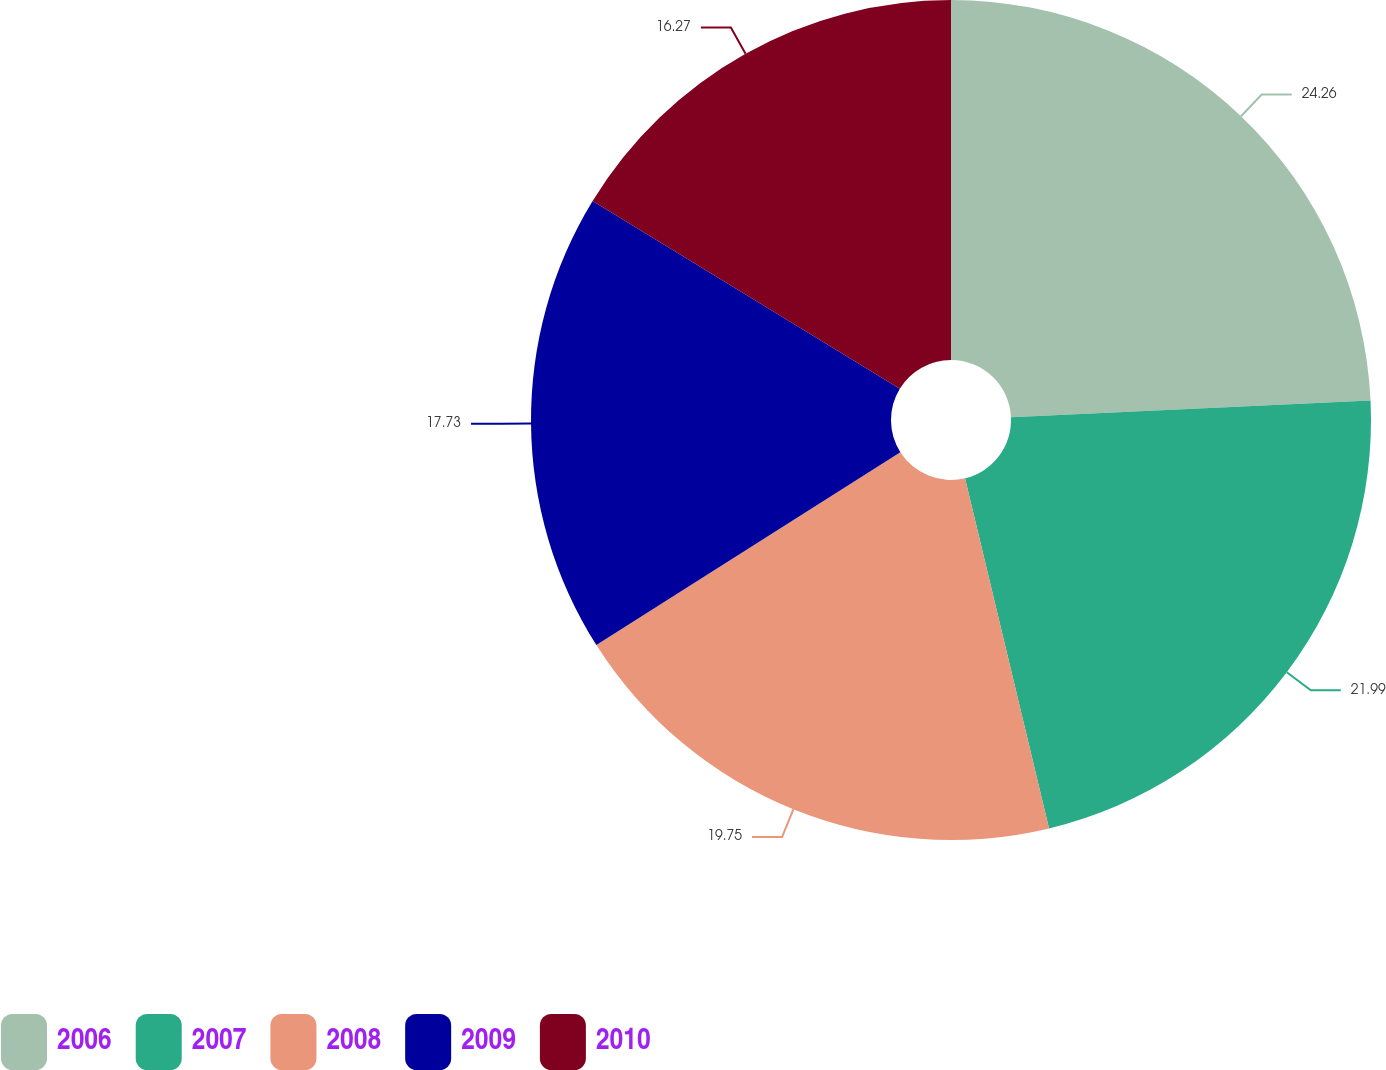Convert chart. <chart><loc_0><loc_0><loc_500><loc_500><pie_chart><fcel>2006<fcel>2007<fcel>2008<fcel>2009<fcel>2010<nl><fcel>24.26%<fcel>21.99%<fcel>19.75%<fcel>17.73%<fcel>16.27%<nl></chart> 